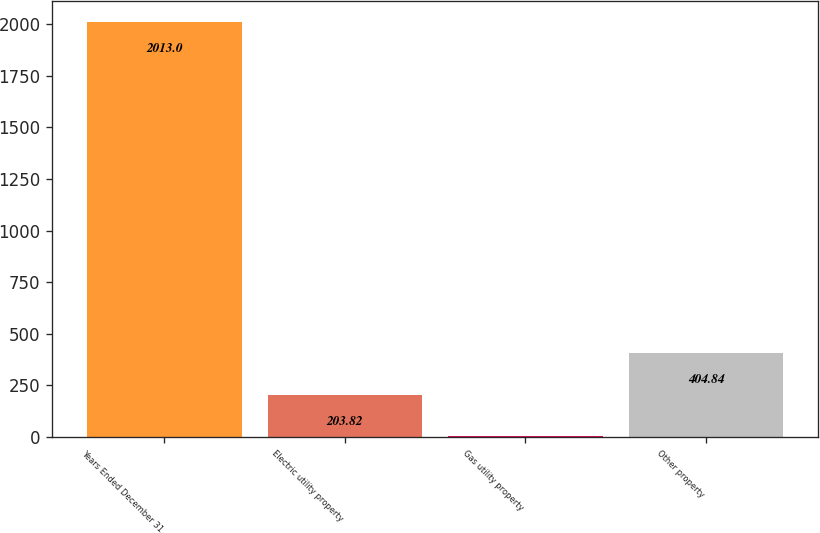Convert chart to OTSL. <chart><loc_0><loc_0><loc_500><loc_500><bar_chart><fcel>Years Ended December 31<fcel>Electric utility property<fcel>Gas utility property<fcel>Other property<nl><fcel>2013<fcel>203.82<fcel>2.8<fcel>404.84<nl></chart> 